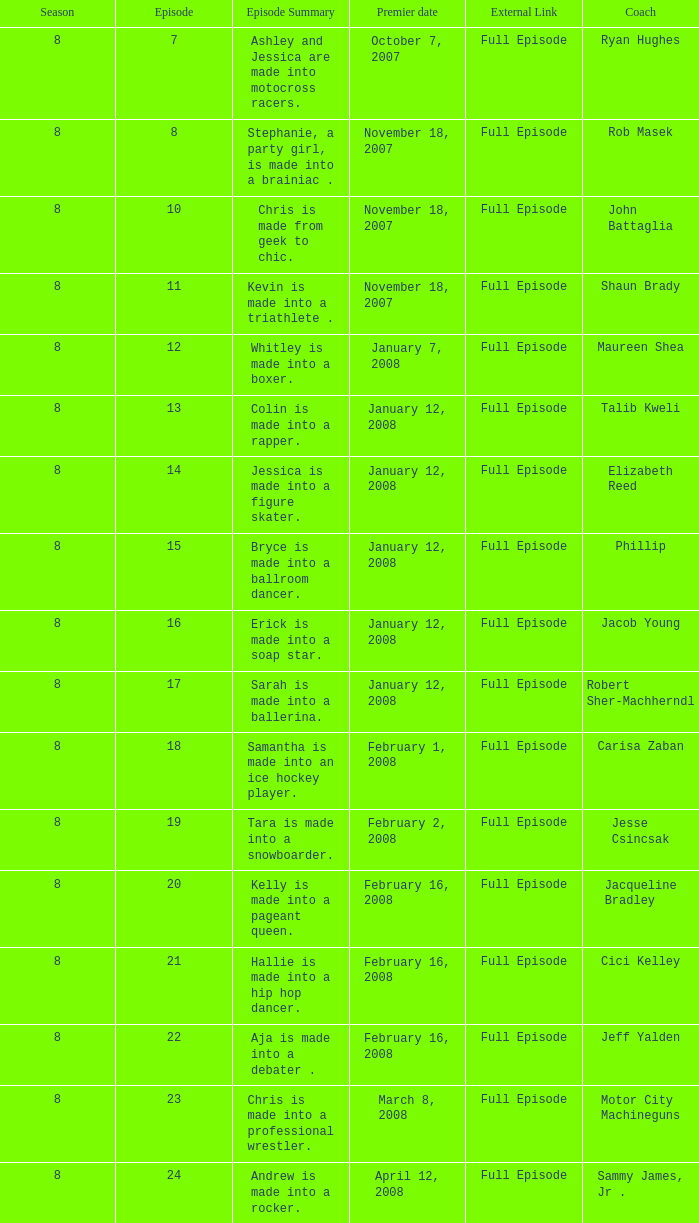How many seasons feature Rob Masek? 1.0. 